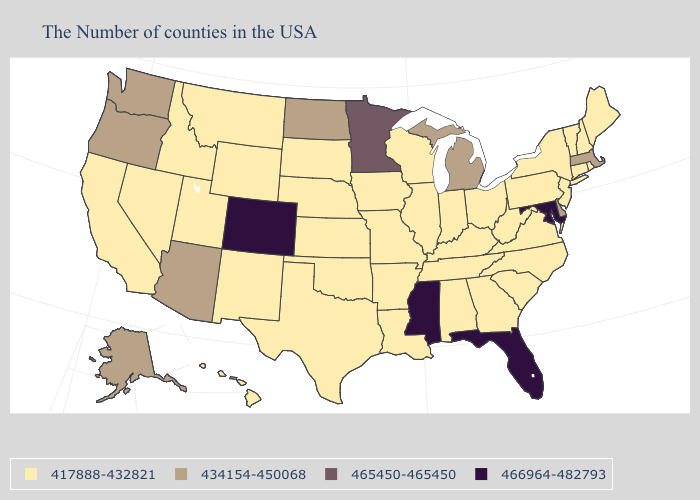Name the states that have a value in the range 417888-432821?
Keep it brief. Maine, Rhode Island, New Hampshire, Vermont, Connecticut, New York, New Jersey, Pennsylvania, Virginia, North Carolina, South Carolina, West Virginia, Ohio, Georgia, Kentucky, Indiana, Alabama, Tennessee, Wisconsin, Illinois, Louisiana, Missouri, Arkansas, Iowa, Kansas, Nebraska, Oklahoma, Texas, South Dakota, Wyoming, New Mexico, Utah, Montana, Idaho, Nevada, California, Hawaii. Name the states that have a value in the range 465450-465450?
Write a very short answer. Minnesota. Does Massachusetts have the highest value in the Northeast?
Concise answer only. Yes. Does the map have missing data?
Give a very brief answer. No. Which states have the highest value in the USA?
Give a very brief answer. Maryland, Florida, Mississippi, Colorado. What is the highest value in the West ?
Give a very brief answer. 466964-482793. Does Arizona have a lower value than Mississippi?
Keep it brief. Yes. What is the highest value in states that border Iowa?
Be succinct. 465450-465450. Among the states that border Colorado , which have the highest value?
Short answer required. Arizona. What is the highest value in the West ?
Quick response, please. 466964-482793. What is the highest value in the Northeast ?
Keep it brief. 434154-450068. Does Oregon have the same value as South Dakota?
Answer briefly. No. What is the lowest value in the USA?
Short answer required. 417888-432821. Does the first symbol in the legend represent the smallest category?
Short answer required. Yes. Does the first symbol in the legend represent the smallest category?
Be succinct. Yes. 